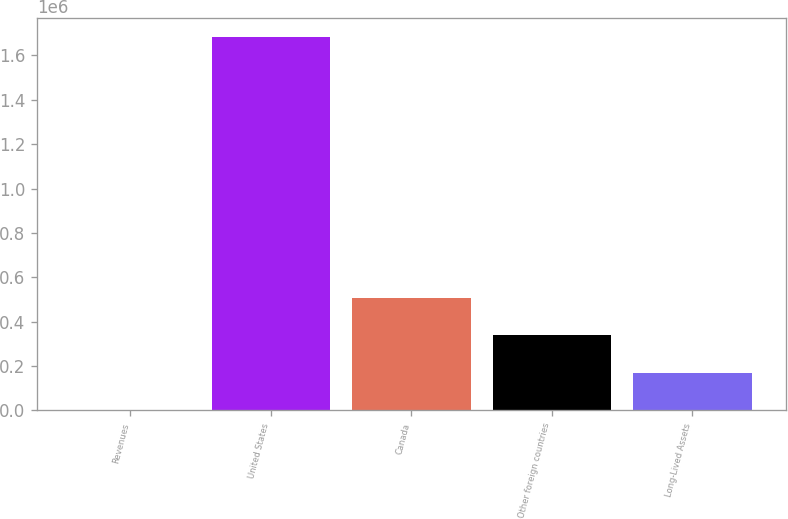Convert chart. <chart><loc_0><loc_0><loc_500><loc_500><bar_chart><fcel>Revenues<fcel>United States<fcel>Canada<fcel>Other foreign countries<fcel>Long-Lived Assets<nl><fcel>2006<fcel>1.68327e+06<fcel>506386<fcel>338259<fcel>170132<nl></chart> 